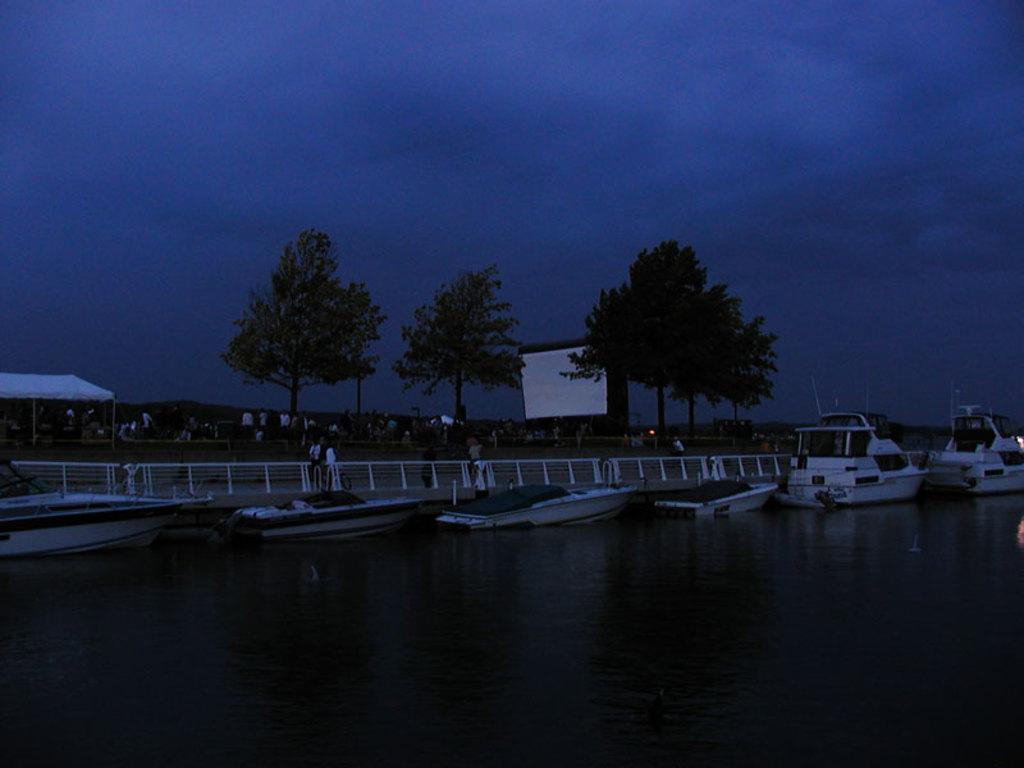Can you describe this image briefly? In the center of the image we can see the sky, trees, boats on the water, fences, one tent, few people and a few other objects. 